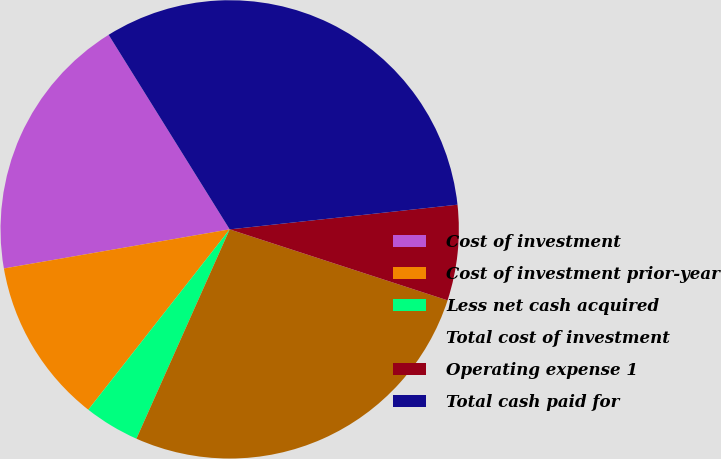<chart> <loc_0><loc_0><loc_500><loc_500><pie_chart><fcel>Cost of investment<fcel>Cost of investment prior-year<fcel>Less net cash acquired<fcel>Total cost of investment<fcel>Operating expense 1<fcel>Total cash paid for<nl><fcel>18.87%<fcel>11.69%<fcel>3.91%<fcel>26.66%<fcel>6.73%<fcel>32.14%<nl></chart> 